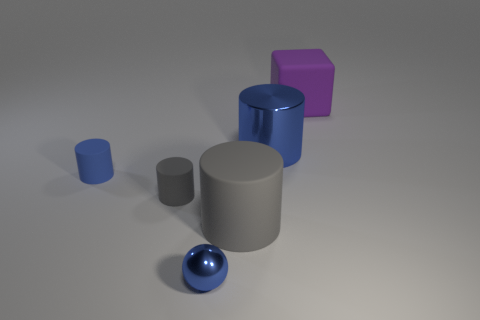There is a blue thing that is the same material as the large blue cylinder; what is its shape?
Make the answer very short. Sphere. There is a gray matte object that is to the left of the blue ball; does it have the same size as the big gray matte cylinder?
Keep it short and to the point. No. There is a gray object behind the large rubber object on the left side of the purple block; what shape is it?
Give a very brief answer. Cylinder. There is a blue metallic object left of the big matte thing left of the large matte block; how big is it?
Provide a succinct answer. Small. What is the color of the tiny cylinder that is behind the small gray rubber thing?
Give a very brief answer. Blue. The other gray object that is made of the same material as the big gray thing is what size?
Make the answer very short. Small. How many other metallic objects are the same shape as the tiny gray thing?
Your response must be concise. 1. What material is the blue object that is the same size as the purple rubber cube?
Your answer should be very brief. Metal. Is there a large purple sphere that has the same material as the large gray thing?
Offer a terse response. No. The tiny thing that is both behind the small sphere and in front of the tiny blue matte cylinder is what color?
Provide a short and direct response. Gray. 